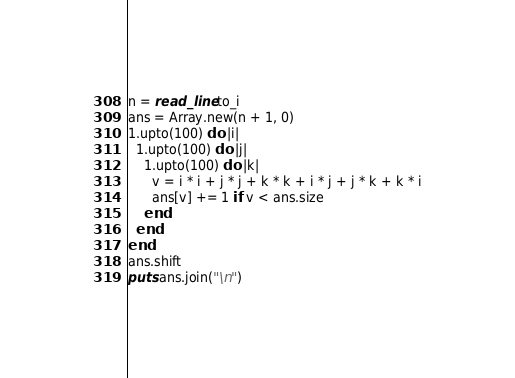<code> <loc_0><loc_0><loc_500><loc_500><_Crystal_>n = read_line.to_i
ans = Array.new(n + 1, 0)
1.upto(100) do |i|
  1.upto(100) do |j|
    1.upto(100) do |k|
      v = i * i + j * j + k * k + i * j + j * k + k * i
      ans[v] += 1 if v < ans.size
    end
  end
end
ans.shift
puts ans.join("\n")
</code> 